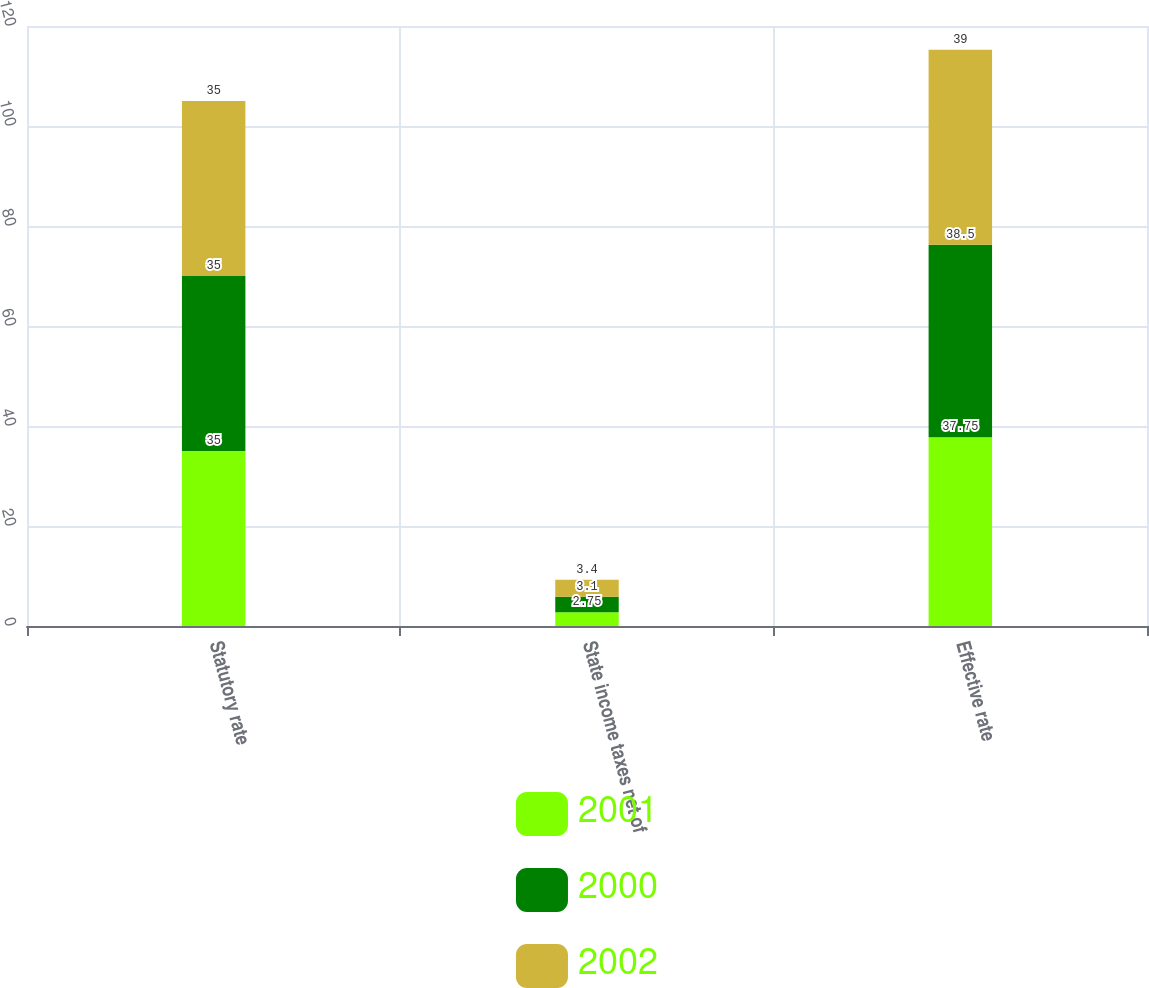<chart> <loc_0><loc_0><loc_500><loc_500><stacked_bar_chart><ecel><fcel>Statutory rate<fcel>State income taxes net of<fcel>Effective rate<nl><fcel>2001<fcel>35<fcel>2.75<fcel>37.75<nl><fcel>2000<fcel>35<fcel>3.1<fcel>38.5<nl><fcel>2002<fcel>35<fcel>3.4<fcel>39<nl></chart> 